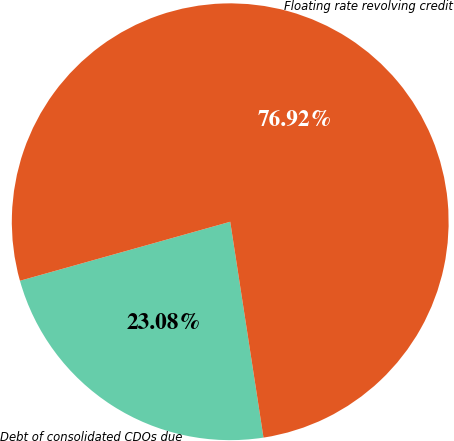Convert chart to OTSL. <chart><loc_0><loc_0><loc_500><loc_500><pie_chart><fcel>Debt of consolidated CDOs due<fcel>Floating rate revolving credit<nl><fcel>23.08%<fcel>76.92%<nl></chart> 